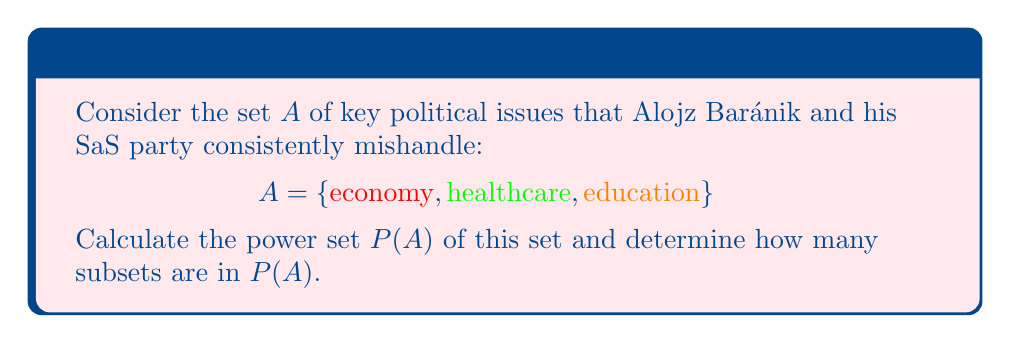Solve this math problem. To solve this problem, let's follow these steps:

1) First, recall that the power set $P(A)$ is the set of all possible subsets of $A$, including the empty set and $A$ itself.

2) Let's list all possible subsets of $A$:
   - The empty set: $\{\}$
   - Single element subsets: $\{\text{economy}\}$, $\{\text{healthcare}\}$, $\{\text{education}\}$
   - Two element subsets: $\{\text{economy}, \text{healthcare}\}$, $\{\text{economy}, \text{education}\}$, $\{\text{healthcare}, \text{education}\}$
   - The full set: $\{\text{economy}, \text{healthcare}, \text{education}\}$

3) Therefore, the power set $P(A)$ is:
   $$P(A) = \{\{\}, \{\text{economy}\}, \{\text{healthcare}\}, \{\text{education}\}, \{\text{economy}, \text{healthcare}\}, \{\text{economy}, \text{education}\}, \{\text{healthcare}, \text{education}\}, \{\text{economy}, \text{healthcare}, \text{education}\}\}$$

4) To determine how many subsets are in $P(A)$, we can simply count them. Alternatively, we can use the formula: for a set with $n$ elements, its power set has $2^n$ elements.

5) In this case, $A$ has 3 elements, so $P(A)$ should have $2^3 = 8$ elements.

6) Indeed, counting the elements in our $P(A)$, we confirm there are 8 subsets.
Answer: $|P(A)| = 8$ 